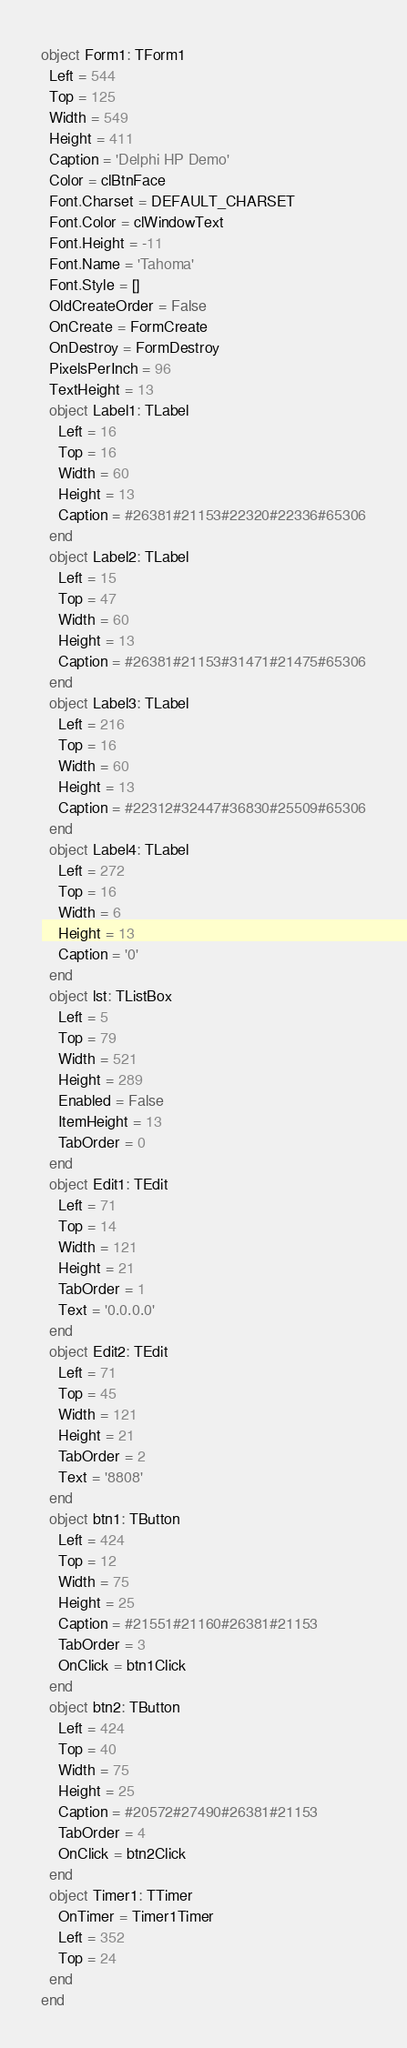Convert code to text. <code><loc_0><loc_0><loc_500><loc_500><_Pascal_>object Form1: TForm1
  Left = 544
  Top = 125
  Width = 549
  Height = 411
  Caption = 'Delphi HP Demo'
  Color = clBtnFace
  Font.Charset = DEFAULT_CHARSET
  Font.Color = clWindowText
  Font.Height = -11
  Font.Name = 'Tahoma'
  Font.Style = []
  OldCreateOrder = False
  OnCreate = FormCreate
  OnDestroy = FormDestroy
  PixelsPerInch = 96
  TextHeight = 13
  object Label1: TLabel
    Left = 16
    Top = 16
    Width = 60
    Height = 13
    Caption = #26381#21153#22320#22336#65306
  end
  object Label2: TLabel
    Left = 15
    Top = 47
    Width = 60
    Height = 13
    Caption = #26381#21153#31471#21475#65306
  end
  object Label3: TLabel
    Left = 216
    Top = 16
    Width = 60
    Height = 13
    Caption = #22312#32447#36830#25509#65306
  end
  object Label4: TLabel
    Left = 272
    Top = 16
    Width = 6
    Height = 13
    Caption = '0'
  end
  object lst: TListBox
    Left = 5
    Top = 79
    Width = 521
    Height = 289
    Enabled = False
    ItemHeight = 13
    TabOrder = 0
  end
  object Edit1: TEdit
    Left = 71
    Top = 14
    Width = 121
    Height = 21
    TabOrder = 1
    Text = '0.0.0.0'
  end
  object Edit2: TEdit
    Left = 71
    Top = 45
    Width = 121
    Height = 21
    TabOrder = 2
    Text = '8808'
  end
  object btn1: TButton
    Left = 424
    Top = 12
    Width = 75
    Height = 25
    Caption = #21551#21160#26381#21153
    TabOrder = 3
    OnClick = btn1Click
  end
  object btn2: TButton
    Left = 424
    Top = 40
    Width = 75
    Height = 25
    Caption = #20572#27490#26381#21153
    TabOrder = 4
    OnClick = btn2Click
  end
  object Timer1: TTimer
    OnTimer = Timer1Timer
    Left = 352
    Top = 24
  end
end
</code> 